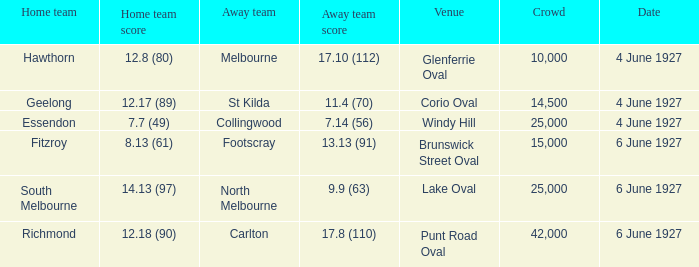Which team was at Corio Oval on 4 June 1927? St Kilda. 